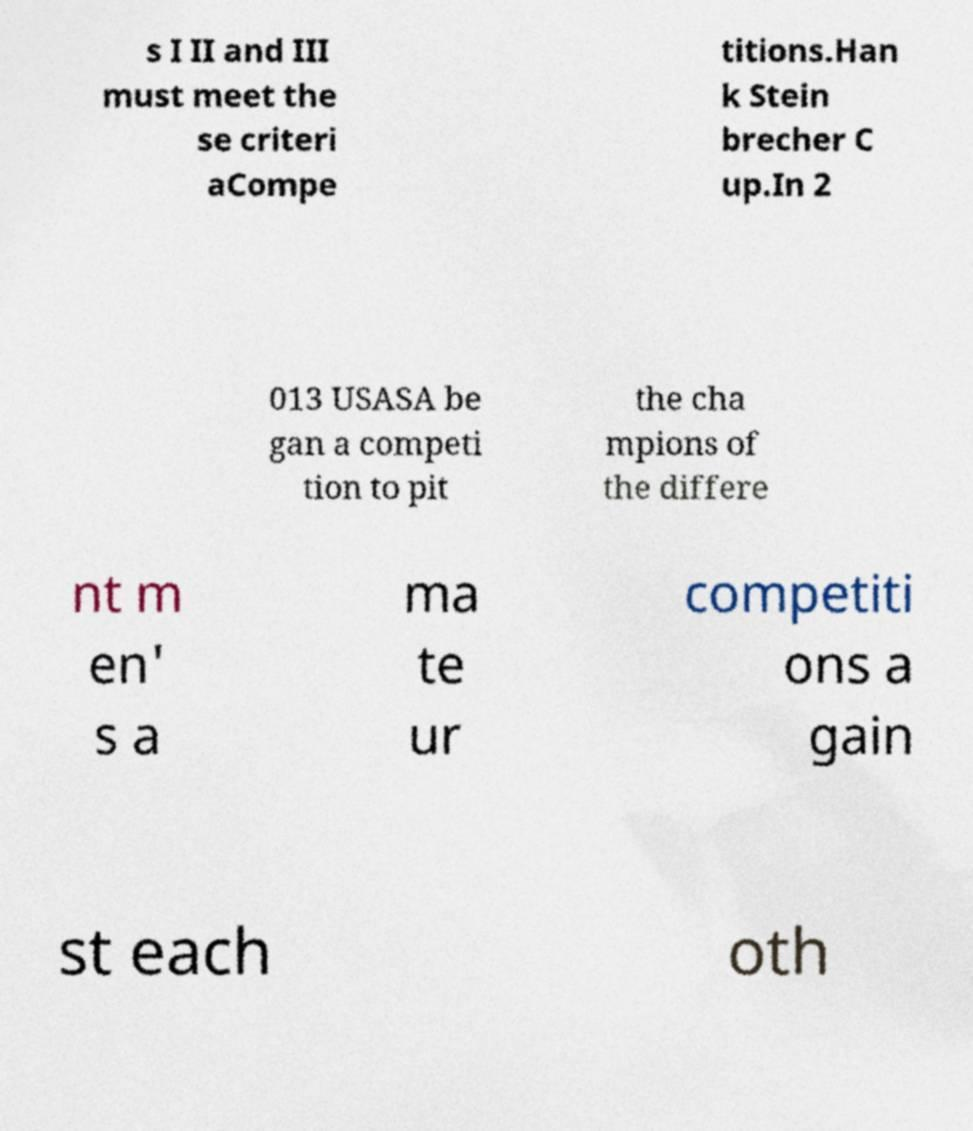Could you extract and type out the text from this image? s I II and III must meet the se criteri aCompe titions.Han k Stein brecher C up.In 2 013 USASA be gan a competi tion to pit the cha mpions of the differe nt m en' s a ma te ur competiti ons a gain st each oth 